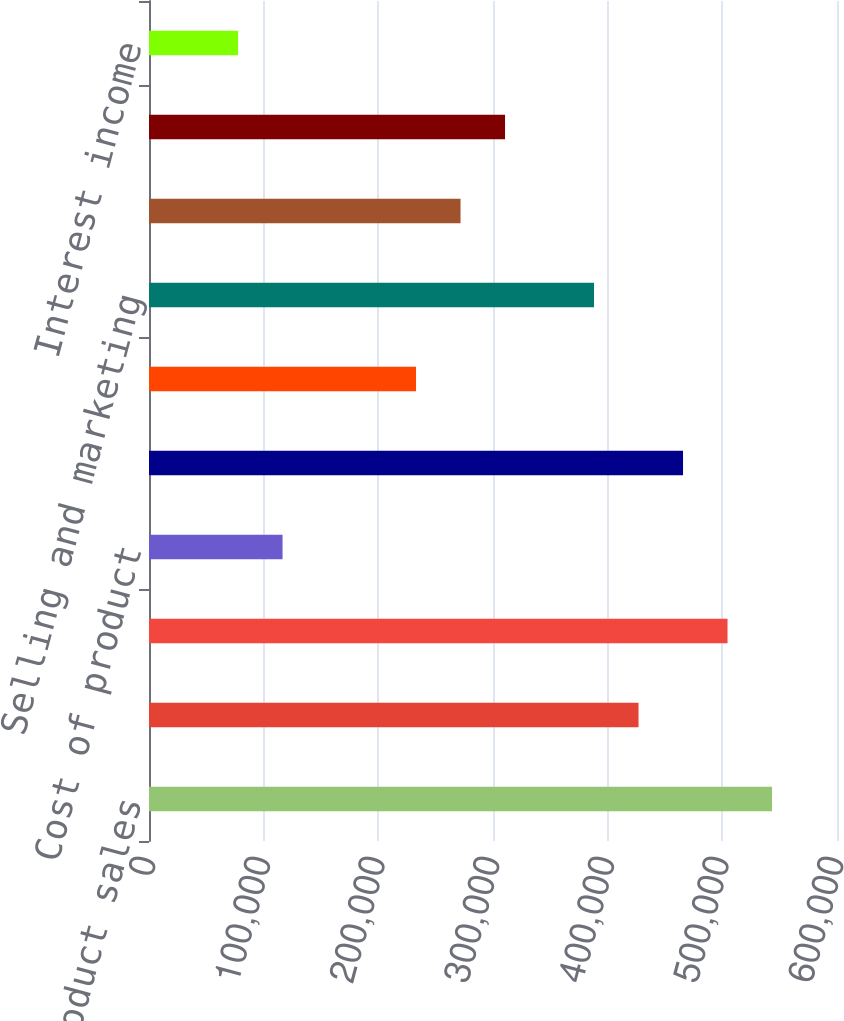Convert chart to OTSL. <chart><loc_0><loc_0><loc_500><loc_500><bar_chart><fcel>Product sales<fcel>Service and other revenues<fcel>Cost of product sales<fcel>Cost of product<fcel>Cost of service and other<fcel>Research and development<fcel>Selling and marketing<fcel>General and administrative<fcel>(Loss) income from operations<fcel>Interest income<nl><fcel>543343<fcel>426919<fcel>504535<fcel>116456<fcel>465727<fcel>232879<fcel>388111<fcel>271687<fcel>310495<fcel>77647.8<nl></chart> 